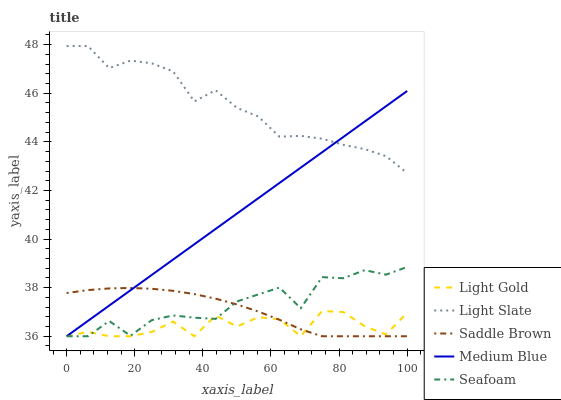Does Light Gold have the minimum area under the curve?
Answer yes or no. Yes. Does Light Slate have the maximum area under the curve?
Answer yes or no. Yes. Does Medium Blue have the minimum area under the curve?
Answer yes or no. No. Does Medium Blue have the maximum area under the curve?
Answer yes or no. No. Is Medium Blue the smoothest?
Answer yes or no. Yes. Is Light Gold the roughest?
Answer yes or no. Yes. Is Light Gold the smoothest?
Answer yes or no. No. Is Medium Blue the roughest?
Answer yes or no. No. Does Medium Blue have the lowest value?
Answer yes or no. Yes. Does Light Slate have the highest value?
Answer yes or no. Yes. Does Medium Blue have the highest value?
Answer yes or no. No. Is Light Gold less than Light Slate?
Answer yes or no. Yes. Is Light Slate greater than Saddle Brown?
Answer yes or no. Yes. Does Medium Blue intersect Light Slate?
Answer yes or no. Yes. Is Medium Blue less than Light Slate?
Answer yes or no. No. Is Medium Blue greater than Light Slate?
Answer yes or no. No. Does Light Gold intersect Light Slate?
Answer yes or no. No. 